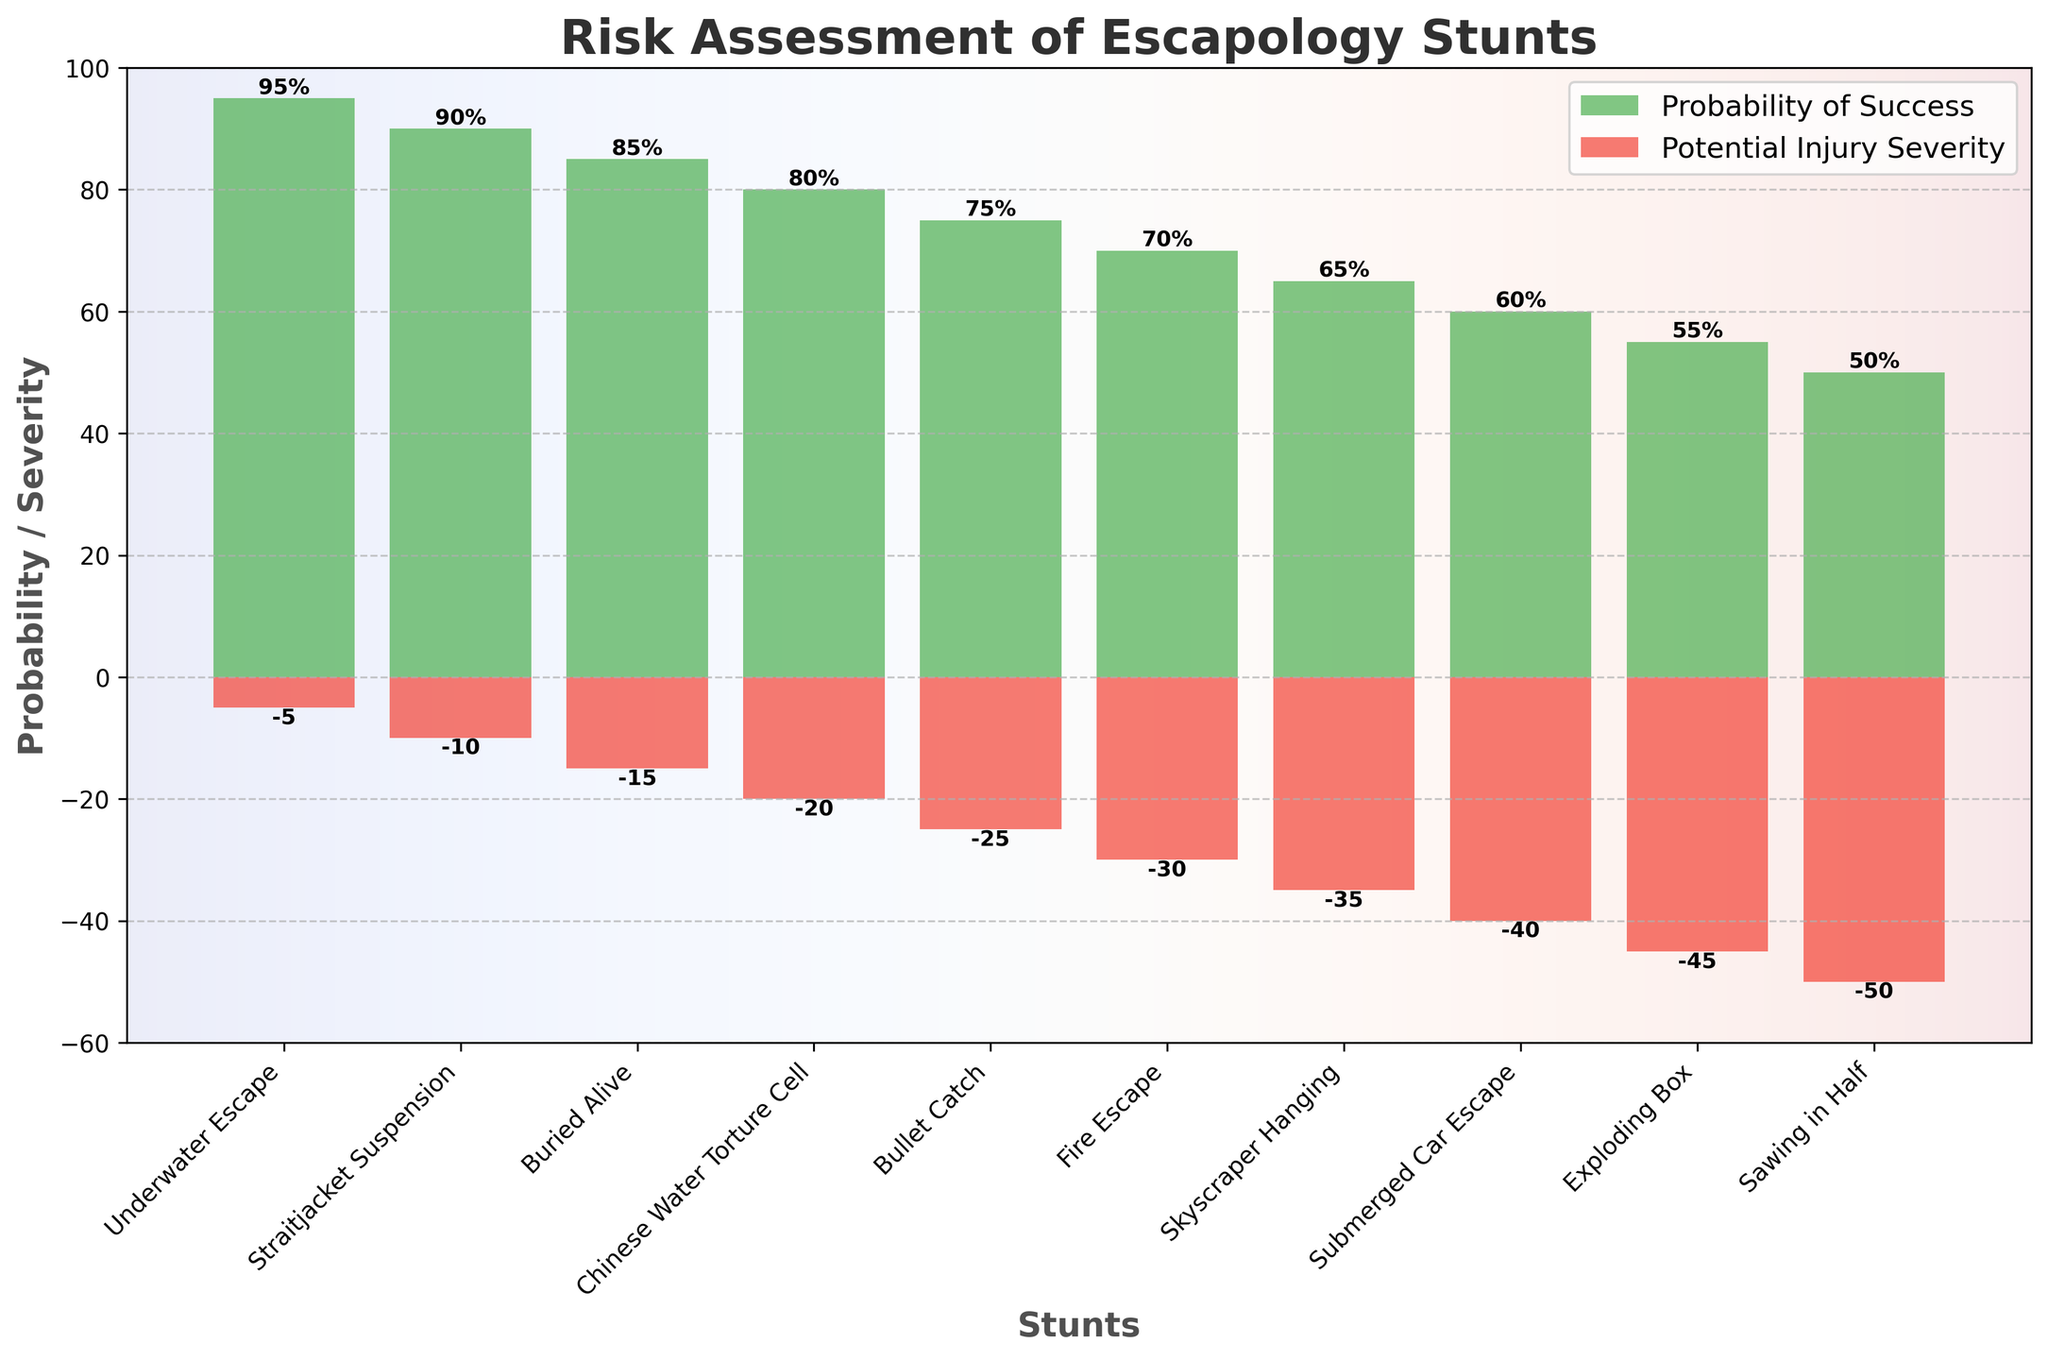What is the title of the figure? The title is written at the top of the figure and summarizes its content. In this case, it reads: "Risk Assessment of Escapology Stunts".
Answer: Risk Assessment of Escapology Stunts What does the green color represent in the figure? The green color represents the probability of success for each stunt as indicated by the legend on the top right.
Answer: Probability of Success Which stunt has the lowest probability of success? By looking at the height of the green bars, the stunt with the lowest probability of success is "Sawing in Half" with a probability of 50%.
Answer: Sawing in Half What is the probability of success for the "Chinese Water Torture Cell"? The height of the green bar for "Chinese Water Torture Cell" shows the probability, which is labeled as 80%.
Answer: 80% What is the potential injury severity for the "Fire Escape"? The height of the red bar for "Fire Escape" shows the potential injury severity. It goes down to -30, which is also labeled.
Answer: -30 Which stunt has the highest potential injury severity? By examining the red bars, the stunt "Sawing in Half" has the highest potential injury severity, going down to -50.
Answer: Sawing in Half What is the difference in probability of success between the "Underwater Escape" and the "Fire Escape"? The "Underwater Escape" has a probability of 95% and the "Fire Escape" has 70%. The difference is 95% - 70% = 25%.
Answer: 25% How many stunts have a probability of success greater than 80%? By counting the green bars that exceed the 80% mark, the stunts are "Underwater Escape", "Straitjacket Suspension", "Buried Alive", and "Chinese Water Torture Cell". This gives us four stunts.
Answer: 4 What is the average potential injury severity of the "Bullet Catch" and "Exploding Box" stunts? The potential injury severities are -25 for "Bullet Catch" and -45 for "Exploding Box". The average is calculated as (-25 + -45) / 2 = -35.
Answer: -35 Which stunt has a higher probability of success, "Skyscraper Hanging" or "Submerged Car Escape"? By comparing the green bars, "Skyscraper Hanging" has a probability of 65% and "Submerged Car Escape" has 60%. Therefore, "Skyscraper Hanging" has a higher probability of success.
Answer: Skyscraper Hanging 